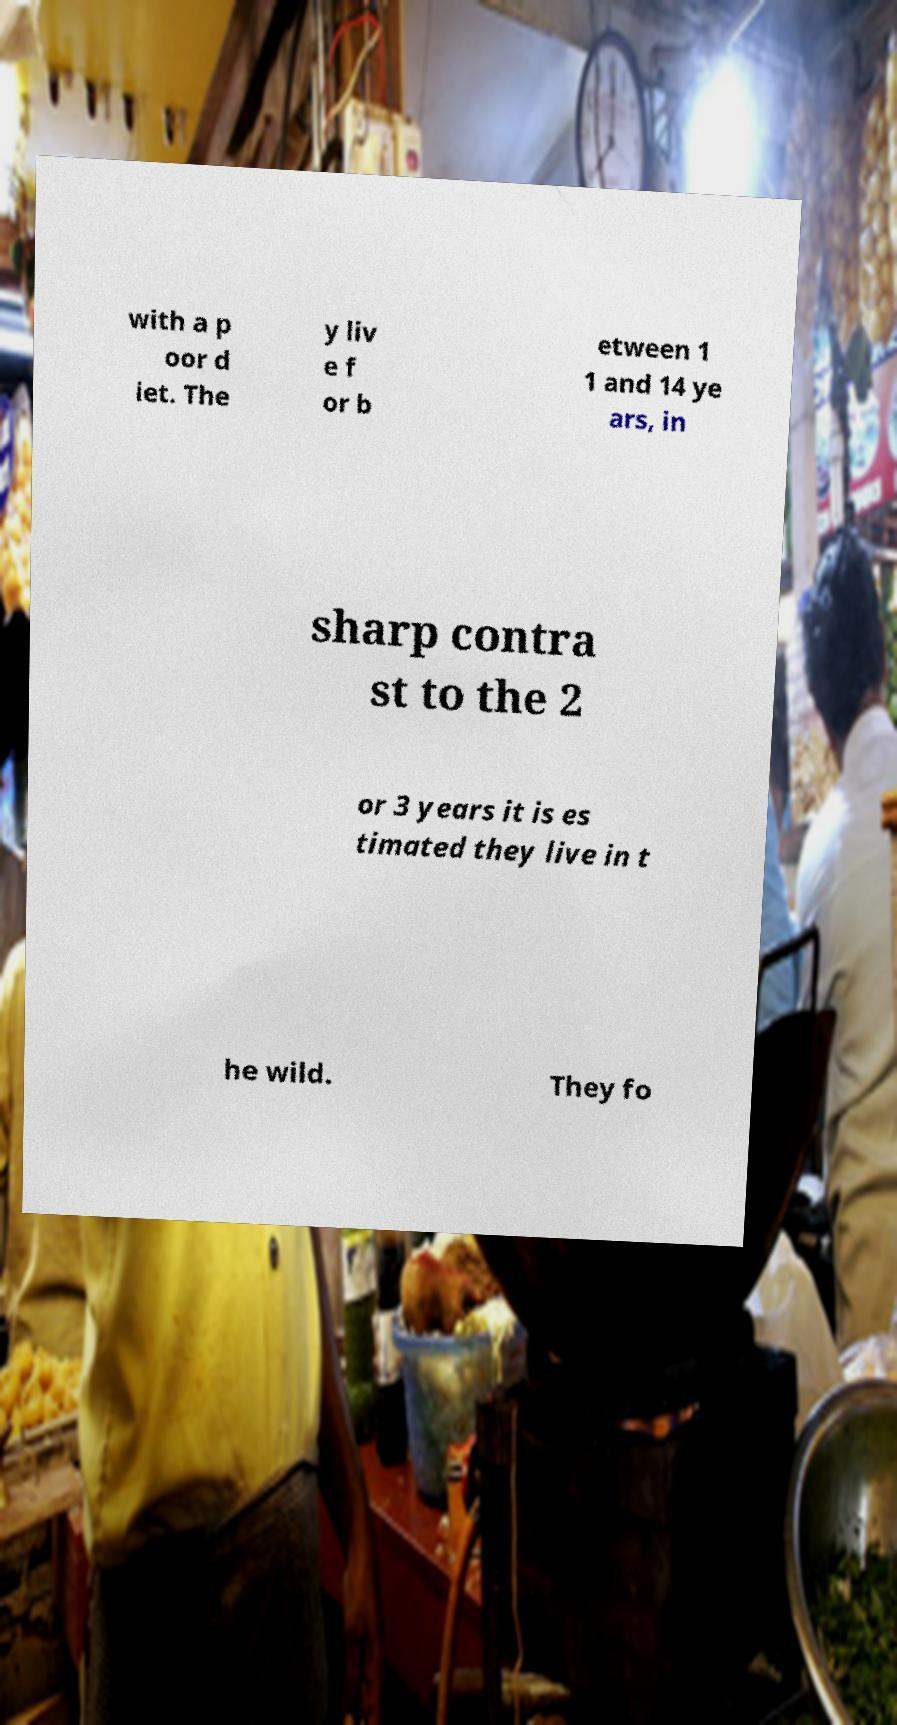Can you accurately transcribe the text from the provided image for me? with a p oor d iet. The y liv e f or b etween 1 1 and 14 ye ars, in sharp contra st to the 2 or 3 years it is es timated they live in t he wild. They fo 